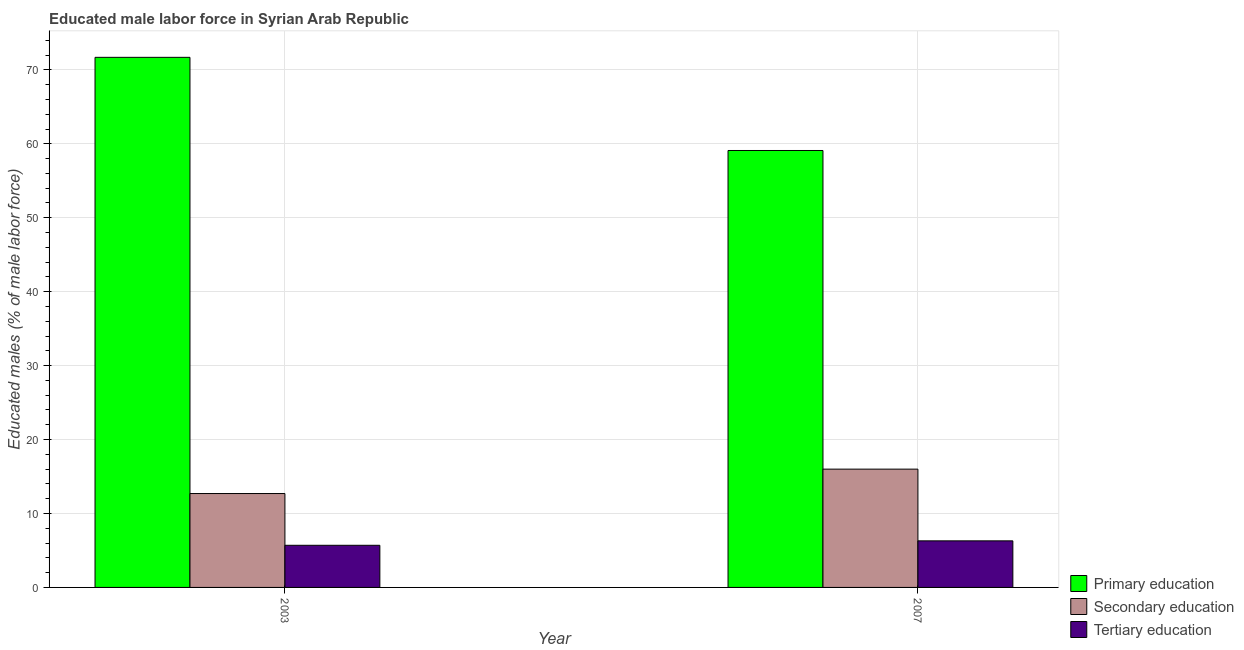Are the number of bars per tick equal to the number of legend labels?
Ensure brevity in your answer.  Yes. Are the number of bars on each tick of the X-axis equal?
Provide a short and direct response. Yes. How many bars are there on the 1st tick from the right?
Provide a short and direct response. 3. In how many cases, is the number of bars for a given year not equal to the number of legend labels?
Make the answer very short. 0. What is the percentage of male labor force who received secondary education in 2003?
Your answer should be very brief. 12.7. Across all years, what is the maximum percentage of male labor force who received primary education?
Make the answer very short. 71.7. Across all years, what is the minimum percentage of male labor force who received secondary education?
Your answer should be compact. 12.7. In which year was the percentage of male labor force who received tertiary education maximum?
Make the answer very short. 2007. In which year was the percentage of male labor force who received tertiary education minimum?
Your response must be concise. 2003. What is the total percentage of male labor force who received primary education in the graph?
Provide a short and direct response. 130.8. What is the difference between the percentage of male labor force who received secondary education in 2003 and that in 2007?
Offer a very short reply. -3.3. What is the difference between the percentage of male labor force who received primary education in 2007 and the percentage of male labor force who received secondary education in 2003?
Offer a terse response. -12.6. What is the average percentage of male labor force who received secondary education per year?
Your response must be concise. 14.35. In the year 2007, what is the difference between the percentage of male labor force who received tertiary education and percentage of male labor force who received secondary education?
Provide a short and direct response. 0. What is the ratio of the percentage of male labor force who received primary education in 2003 to that in 2007?
Make the answer very short. 1.21. What does the 2nd bar from the left in 2003 represents?
Your answer should be compact. Secondary education. What does the 1st bar from the right in 2003 represents?
Give a very brief answer. Tertiary education. Are all the bars in the graph horizontal?
Keep it short and to the point. No. What is the difference between two consecutive major ticks on the Y-axis?
Keep it short and to the point. 10. Does the graph contain grids?
Your response must be concise. Yes. What is the title of the graph?
Offer a very short reply. Educated male labor force in Syrian Arab Republic. Does "Ages 15-20" appear as one of the legend labels in the graph?
Make the answer very short. No. What is the label or title of the Y-axis?
Your answer should be compact. Educated males (% of male labor force). What is the Educated males (% of male labor force) in Primary education in 2003?
Offer a very short reply. 71.7. What is the Educated males (% of male labor force) of Secondary education in 2003?
Provide a short and direct response. 12.7. What is the Educated males (% of male labor force) in Tertiary education in 2003?
Keep it short and to the point. 5.7. What is the Educated males (% of male labor force) in Primary education in 2007?
Provide a short and direct response. 59.1. What is the Educated males (% of male labor force) of Secondary education in 2007?
Provide a succinct answer. 16. What is the Educated males (% of male labor force) in Tertiary education in 2007?
Offer a terse response. 6.3. Across all years, what is the maximum Educated males (% of male labor force) of Primary education?
Offer a terse response. 71.7. Across all years, what is the maximum Educated males (% of male labor force) of Secondary education?
Make the answer very short. 16. Across all years, what is the maximum Educated males (% of male labor force) of Tertiary education?
Your answer should be very brief. 6.3. Across all years, what is the minimum Educated males (% of male labor force) in Primary education?
Offer a terse response. 59.1. Across all years, what is the minimum Educated males (% of male labor force) of Secondary education?
Make the answer very short. 12.7. Across all years, what is the minimum Educated males (% of male labor force) of Tertiary education?
Offer a very short reply. 5.7. What is the total Educated males (% of male labor force) in Primary education in the graph?
Give a very brief answer. 130.8. What is the total Educated males (% of male labor force) of Secondary education in the graph?
Provide a succinct answer. 28.7. What is the difference between the Educated males (% of male labor force) of Primary education in 2003 and the Educated males (% of male labor force) of Secondary education in 2007?
Make the answer very short. 55.7. What is the difference between the Educated males (% of male labor force) in Primary education in 2003 and the Educated males (% of male labor force) in Tertiary education in 2007?
Offer a very short reply. 65.4. What is the average Educated males (% of male labor force) of Primary education per year?
Give a very brief answer. 65.4. What is the average Educated males (% of male labor force) in Secondary education per year?
Provide a short and direct response. 14.35. In the year 2003, what is the difference between the Educated males (% of male labor force) in Primary education and Educated males (% of male labor force) in Secondary education?
Provide a succinct answer. 59. In the year 2007, what is the difference between the Educated males (% of male labor force) of Primary education and Educated males (% of male labor force) of Secondary education?
Offer a very short reply. 43.1. In the year 2007, what is the difference between the Educated males (% of male labor force) in Primary education and Educated males (% of male labor force) in Tertiary education?
Your response must be concise. 52.8. In the year 2007, what is the difference between the Educated males (% of male labor force) in Secondary education and Educated males (% of male labor force) in Tertiary education?
Offer a terse response. 9.7. What is the ratio of the Educated males (% of male labor force) of Primary education in 2003 to that in 2007?
Provide a succinct answer. 1.21. What is the ratio of the Educated males (% of male labor force) in Secondary education in 2003 to that in 2007?
Make the answer very short. 0.79. What is the ratio of the Educated males (% of male labor force) in Tertiary education in 2003 to that in 2007?
Your response must be concise. 0.9. What is the difference between the highest and the second highest Educated males (% of male labor force) of Primary education?
Your answer should be compact. 12.6. What is the difference between the highest and the second highest Educated males (% of male labor force) of Secondary education?
Your answer should be compact. 3.3. What is the difference between the highest and the lowest Educated males (% of male labor force) of Primary education?
Keep it short and to the point. 12.6. 